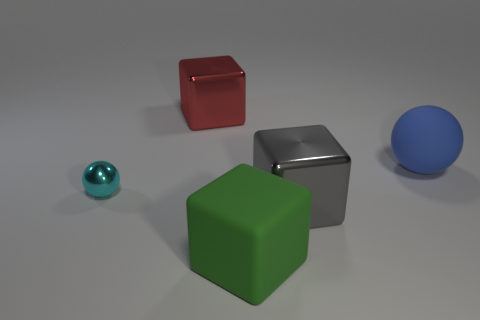Add 3 yellow rubber cylinders. How many objects exist? 8 Subtract all cubes. How many objects are left? 2 Subtract 0 green cylinders. How many objects are left? 5 Subtract all tiny blue shiny blocks. Subtract all blue spheres. How many objects are left? 4 Add 2 gray metallic cubes. How many gray metallic cubes are left? 3 Add 1 green blocks. How many green blocks exist? 2 